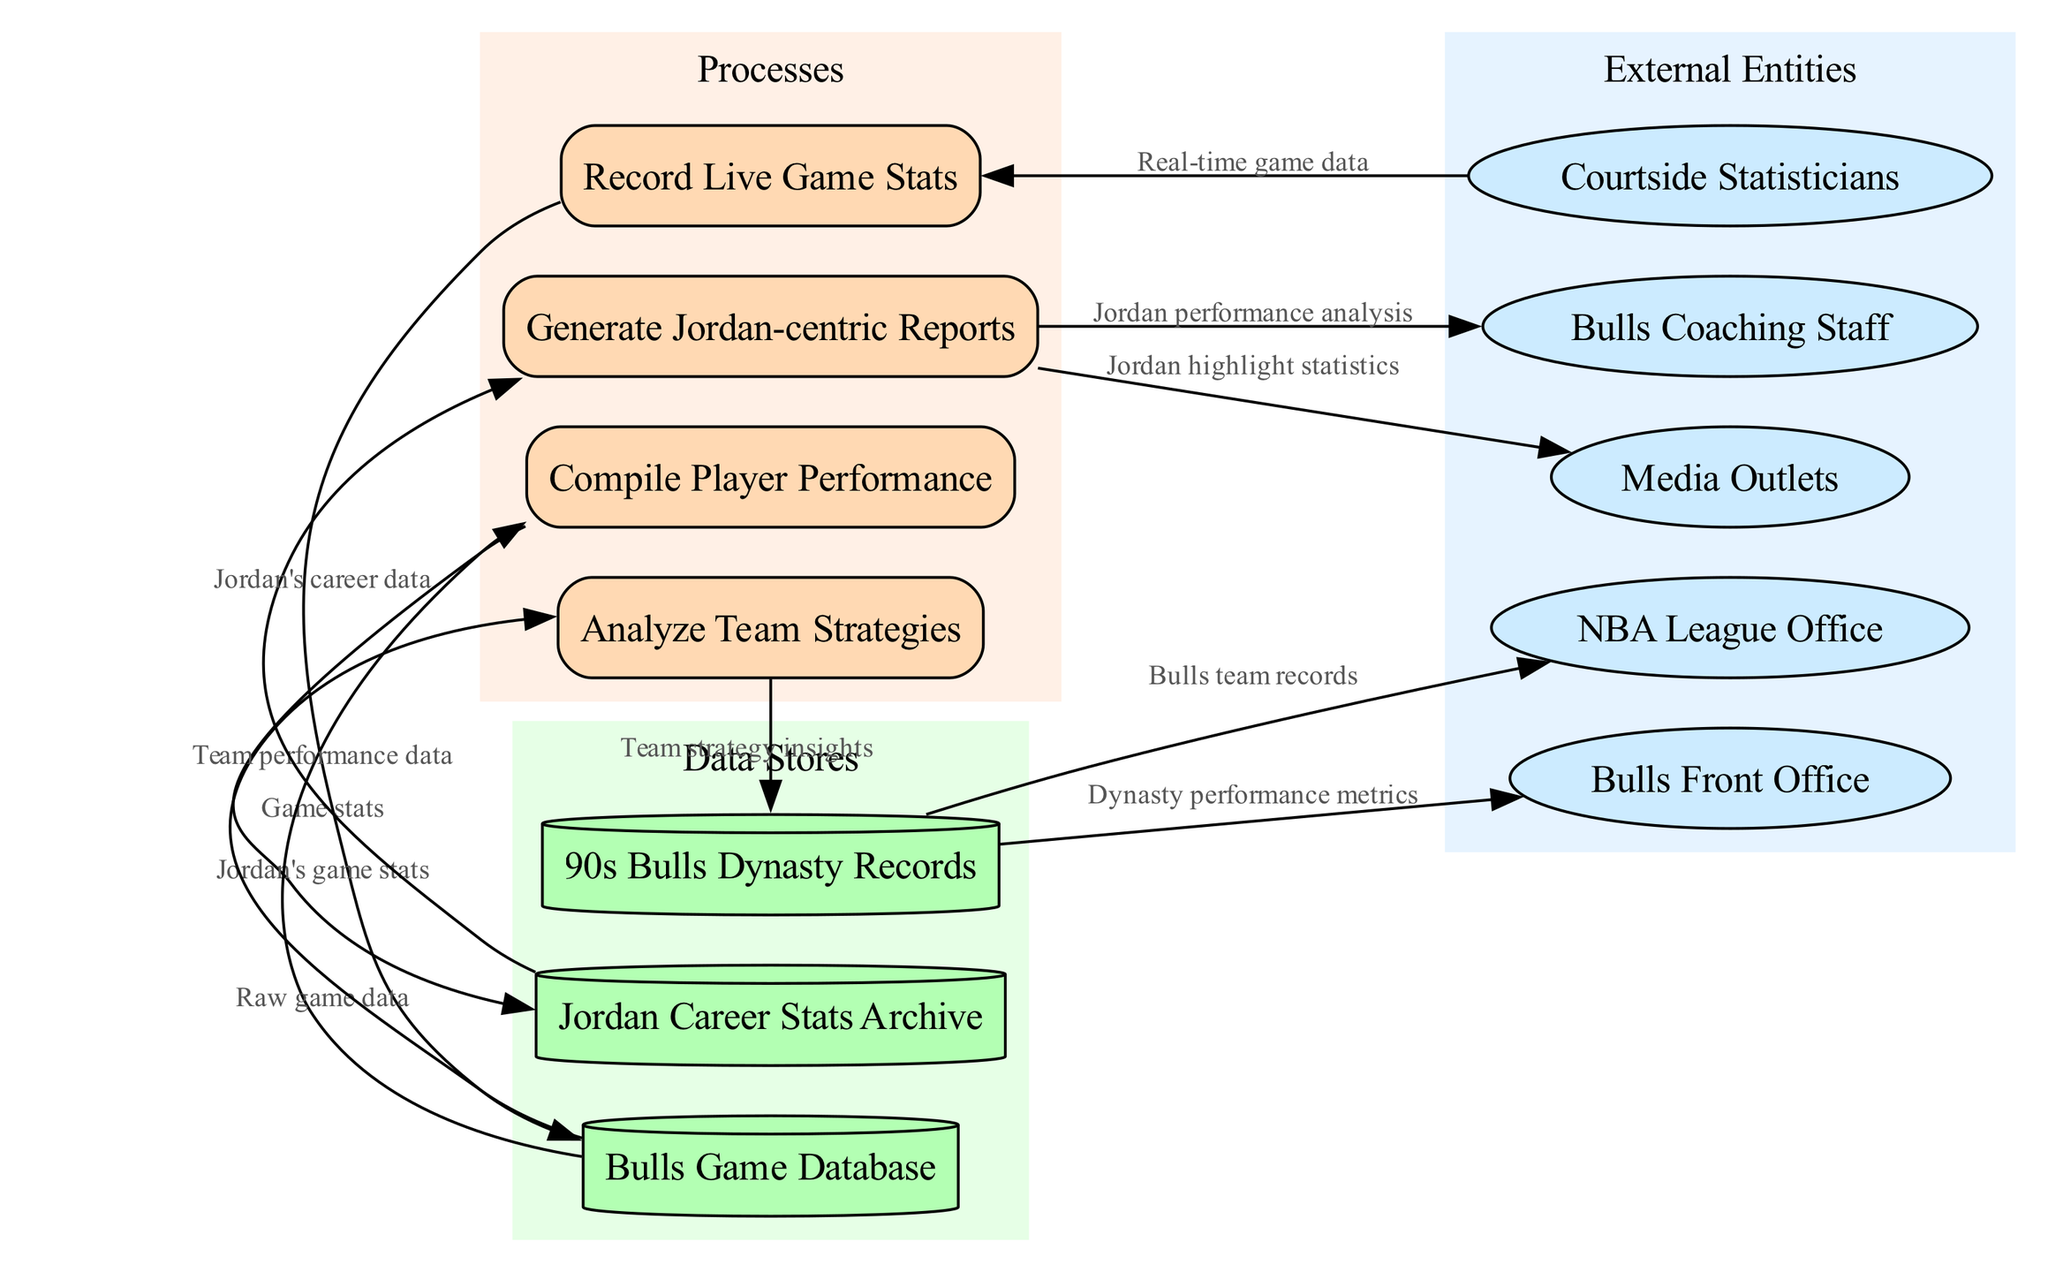What entities provide real-time data? The diagram shows that real-time game data is provided by "Courtside Statisticians." This can be directly observed from the data flow leading from "Courtside Statisticians" to "Record Live Game Stats."
Answer: Courtside Statisticians How many processes are in the diagram? The diagram lists four processes: "Record Live Game Stats," "Compile Player Performance," "Analyze Team Strategies," and "Generate Jordan-centric Reports." Adding these, we find there are four distinct processes.
Answer: 4 What type of data flows into the Bulls Game Database? The data flow into the "Bulls Game Database" from "Record Live Game Stats" is labeled "Game stats." This implies that the type of data being stored in the database comes from the recorded game statistics.
Answer: Game stats Which reports are generated for the Bulls Coaching Staff? The "Generate Jordan-centric Reports" process sends "Jordan performance analysis" to the "Bulls Coaching Staff." This indicates that the reports they receive are focused on analyzing Michael Jordan's performance specifically.
Answer: Jordan performance analysis What data store does the "Analyze Team Strategies" process use? The "Analyze Team Strategies" process receives input data from the "Bulls Game Database." This relationship is depicted in the diagram and shows that team performance data is required for analysis.
Answer: Bulls Game Database How many data stores are represented in the diagram? There are three data stores present: "Bulls Game Database," "Jordan Career Stats Archive," and "90s Bulls Dynasty Records." Counting them gives a total of three distinct data stores.
Answer: 3 What insights are generated from the Analyze Team Strategies process? The output from the "Analyze Team Strategies" process that flows into "90s Bulls Dynasty Records" is labeled "Team strategy insights." This indicates that the insights produced relate specifically to the team's strategies.
Answer: Team strategy insights What is sent to the NBA League Office? The process of handling data from the "90s Bulls Dynasty Records" sends "Bulls team records" to the "NBA League Office." This flow indicates the type of information reported to the league office.
Answer: Bulls team records What type of statistics do Media Outlets receive? Media Outlets receive "Jordan highlight statistics" as an output from the "Generate Jordan-centric Reports." This data flow indicates the specific statistics being shared with media organizations.
Answer: Jordan highlight statistics 